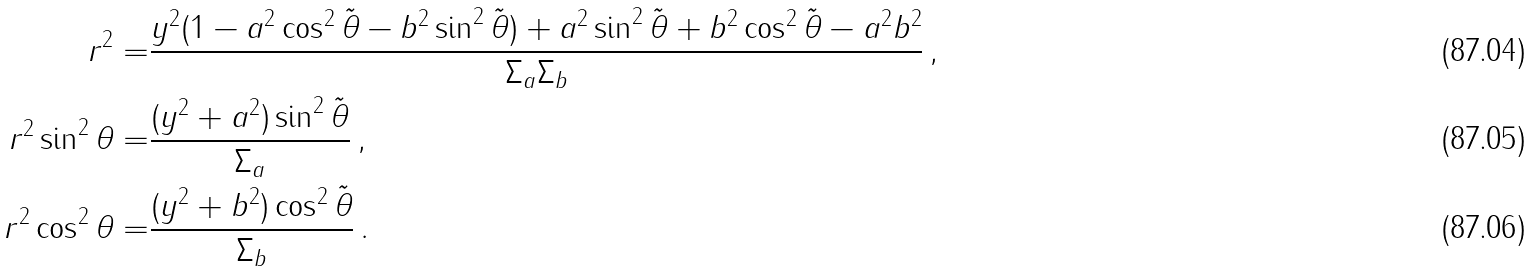Convert formula to latex. <formula><loc_0><loc_0><loc_500><loc_500>r ^ { 2 } = & \frac { y ^ { 2 } ( 1 - a ^ { 2 } \cos ^ { 2 } \tilde { \theta } - b ^ { 2 } \sin ^ { 2 } \tilde { \theta } ) + a ^ { 2 } \sin ^ { 2 } \tilde { \theta } + b ^ { 2 } \cos ^ { 2 } \tilde { \theta } - a ^ { 2 } b ^ { 2 } } { \Sigma _ { a } \Sigma _ { b } } \, , \\ r ^ { 2 } \sin ^ { 2 } \theta = & \frac { ( y ^ { 2 } + a ^ { 2 } ) \sin ^ { 2 } \tilde { \theta } } { \Sigma _ { a } } \, , \\ r ^ { 2 } \cos ^ { 2 } \theta = & \frac { ( y ^ { 2 } + b ^ { 2 } ) \cos ^ { 2 } \tilde { \theta } } { \Sigma _ { b } } \, .</formula> 